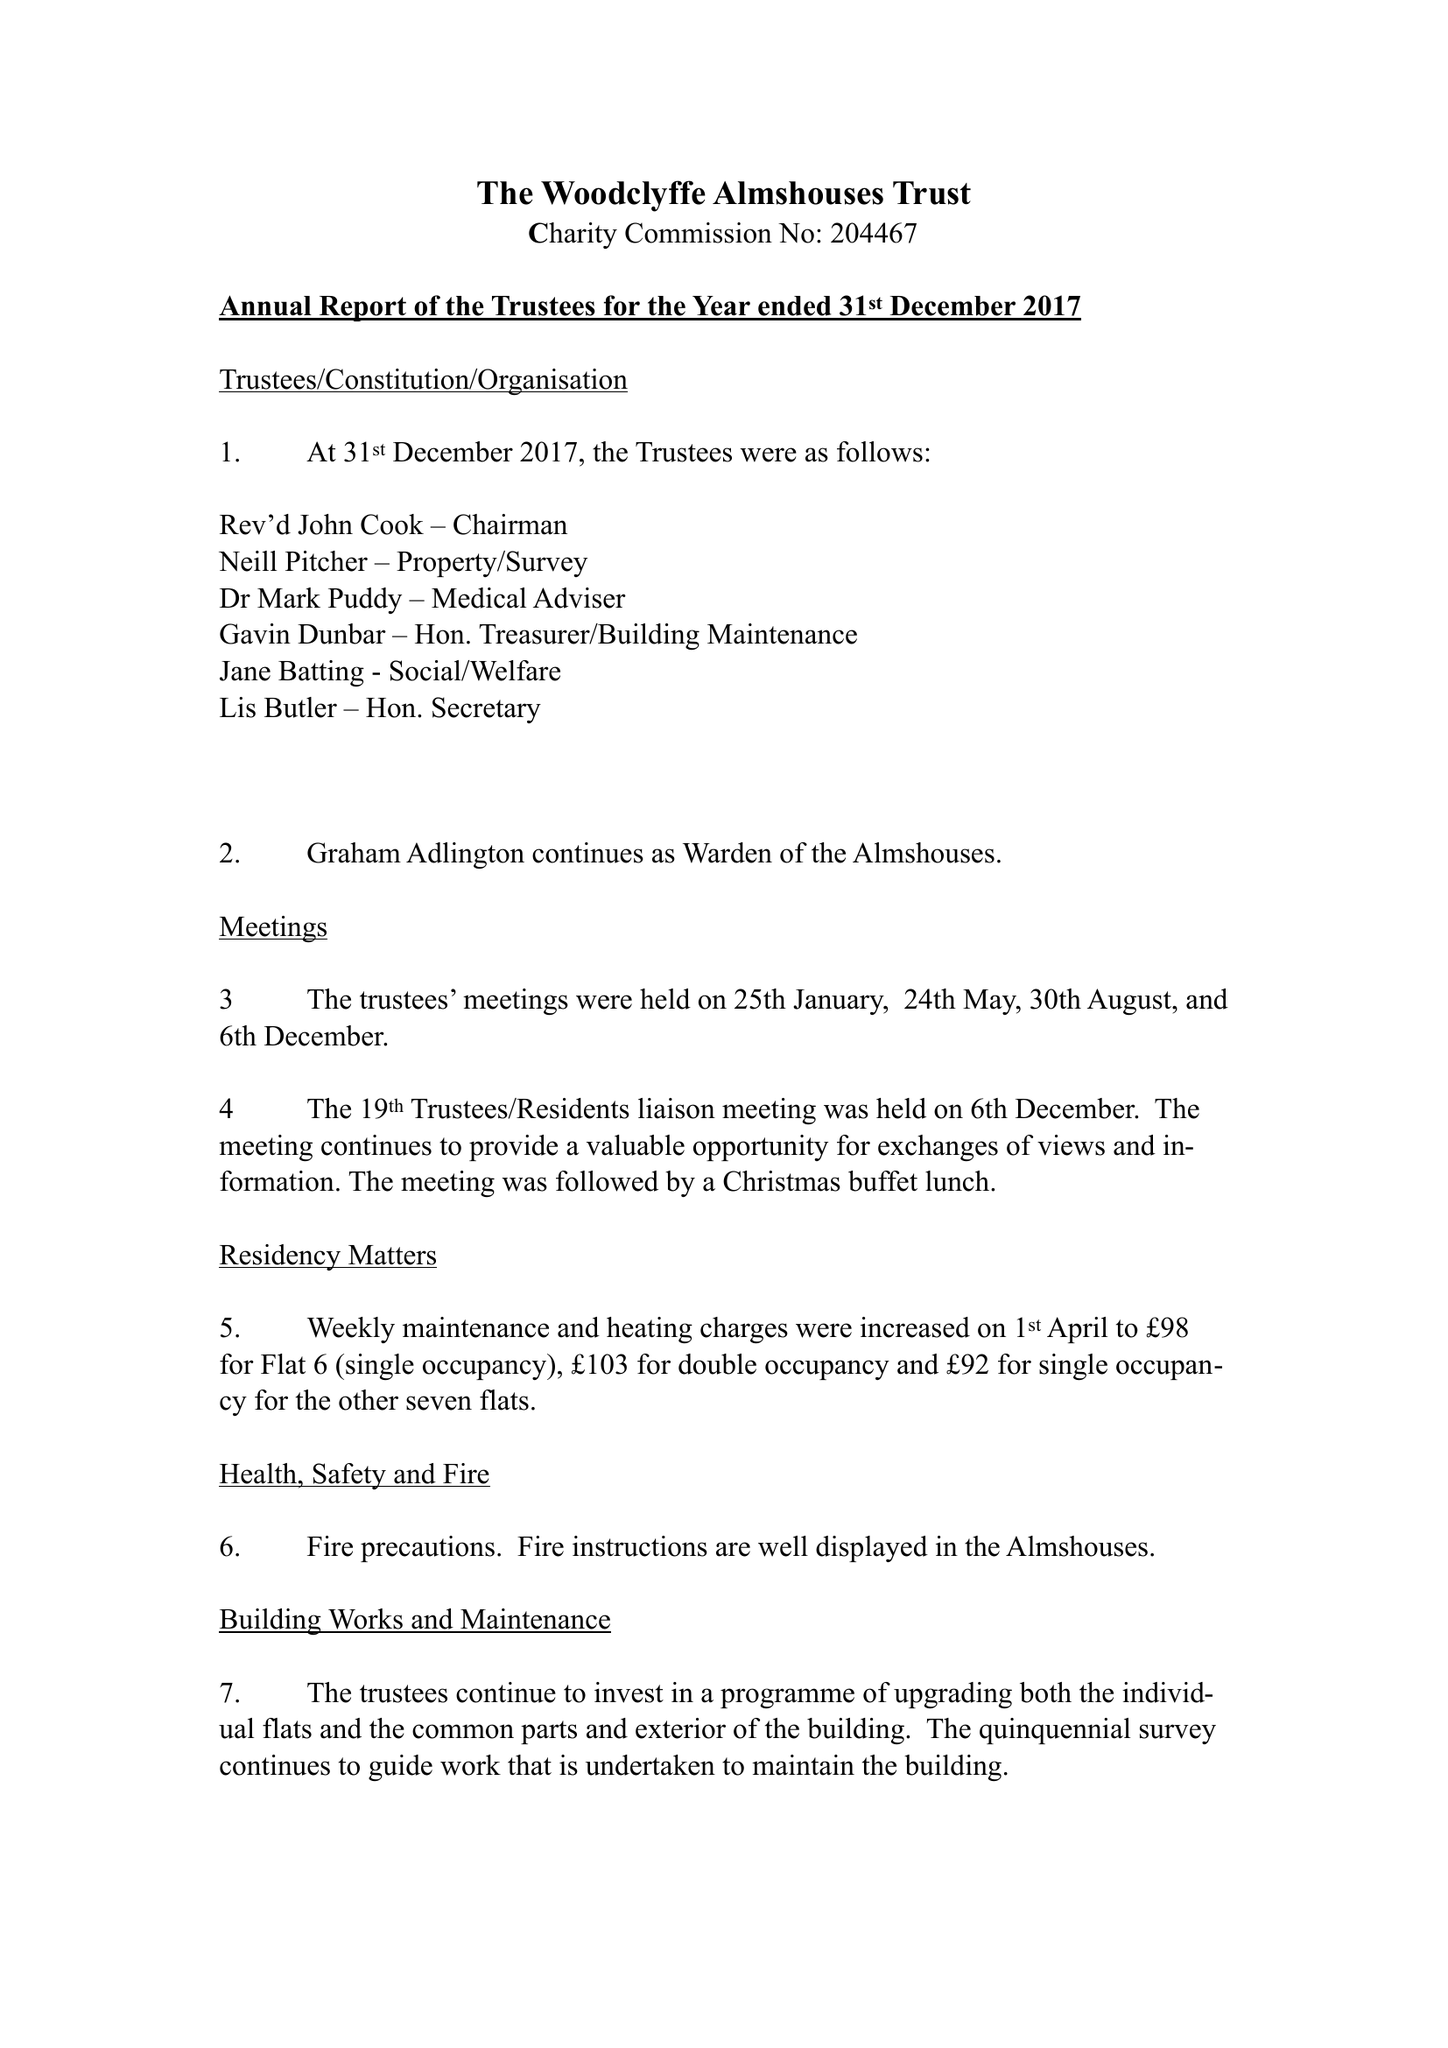What is the value for the report_date?
Answer the question using a single word or phrase. 2017-12-31 